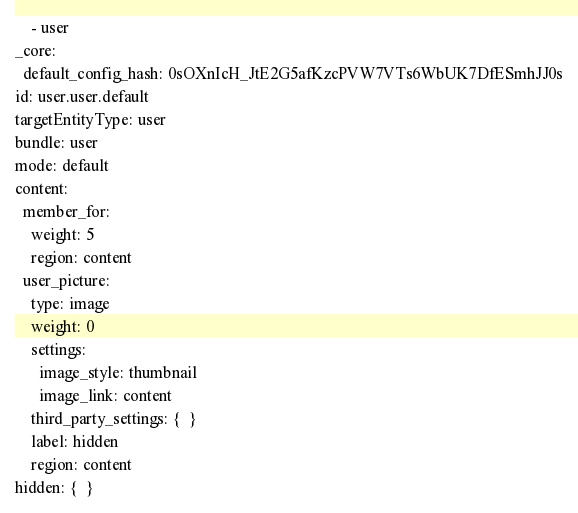Convert code to text. <code><loc_0><loc_0><loc_500><loc_500><_YAML_>    - user
_core:
  default_config_hash: 0sOXnIcH_JtE2G5afKzcPVW7VTs6WbUK7DfESmhJJ0s
id: user.user.default
targetEntityType: user
bundle: user
mode: default
content:
  member_for:
    weight: 5
    region: content
  user_picture:
    type: image
    weight: 0
    settings:
      image_style: thumbnail
      image_link: content
    third_party_settings: {  }
    label: hidden
    region: content
hidden: {  }
</code> 